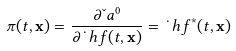<formula> <loc_0><loc_0><loc_500><loc_500>\pi ( t , \mathbf x ) = \frac { \partial \L a ^ { 0 } } { \partial \dot { \ } h f ( t , \mathbf x ) } = \dot { \ } h f ^ { * } ( t , \mathbf x )</formula> 